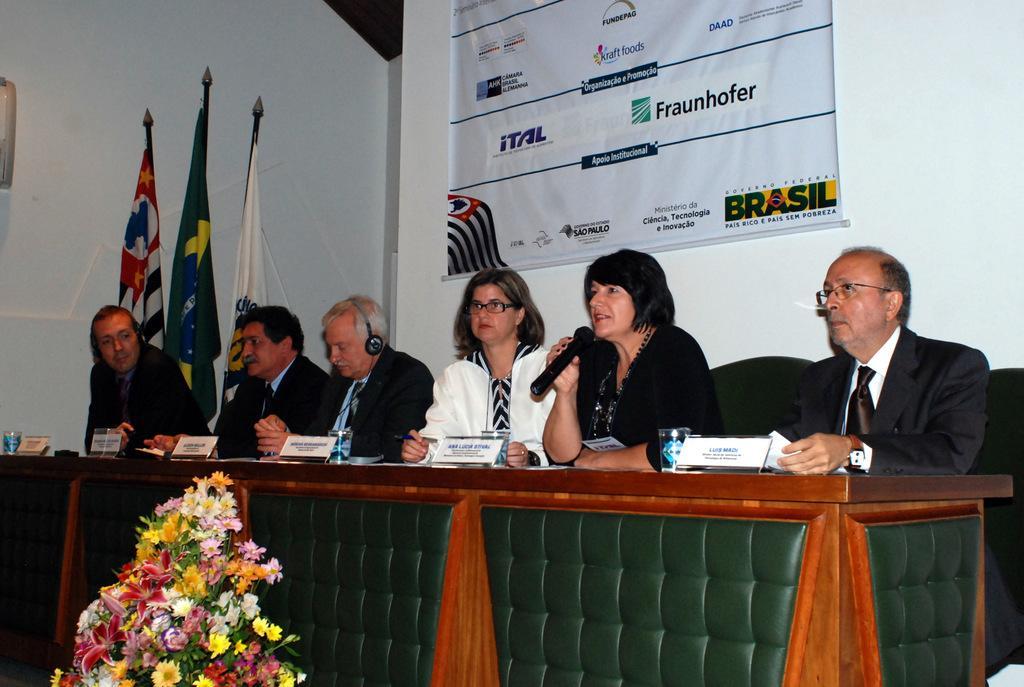Could you give a brief overview of what you see in this image? In this picture we can see a group of people sitting on chairs, name boards, flags, glasses, flower bouquet and a woman holding a mic with her hand and in the background we can see a banner on the wall. 